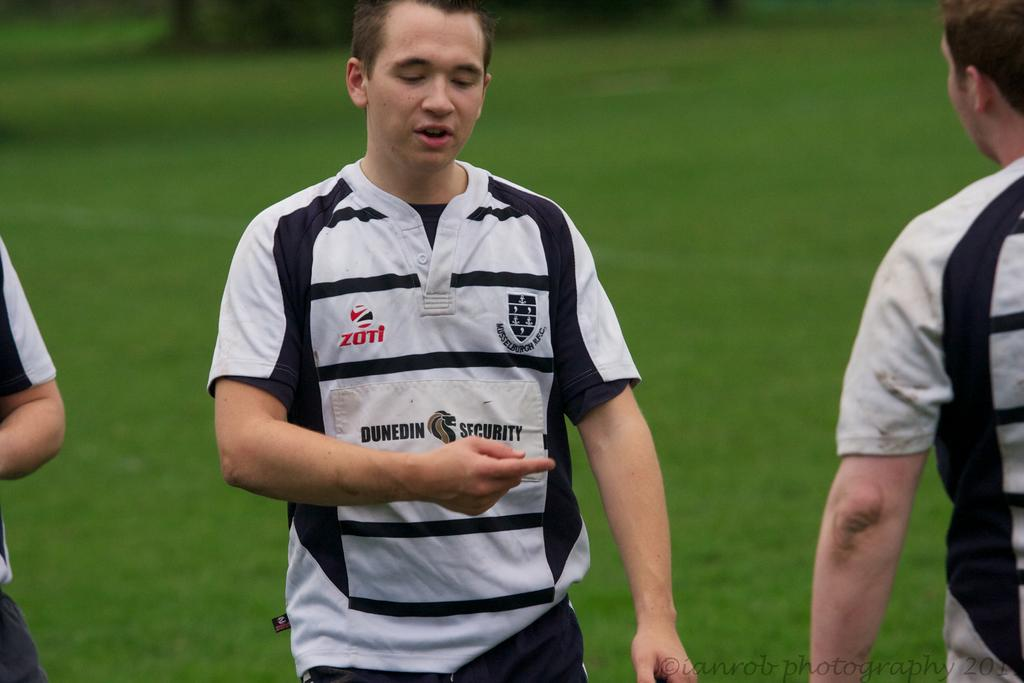<image>
Share a concise interpretation of the image provided. A soccer player with a shirt that says Dunedin Security is pointing to another player. 